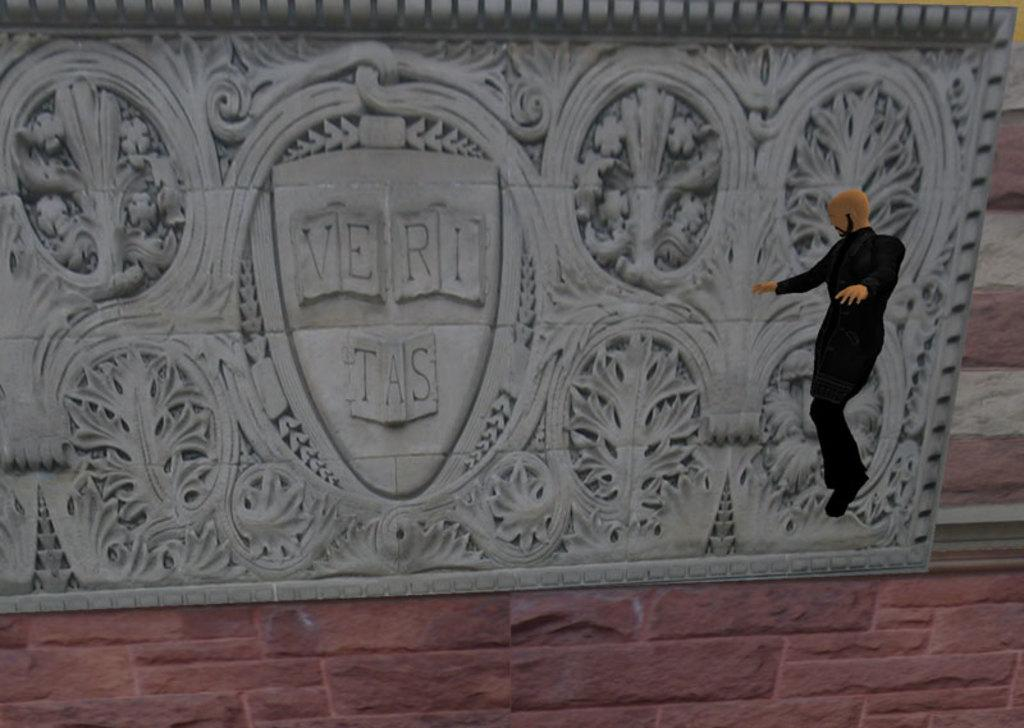What is present on the wall in the image? There is a designed board on the wall. Where is the doll located in the image? The doll is on the right side of the image. Can you describe the wall in the image? The wall has a designed board on it. What type of cave can be seen in the background of the image? There is no cave present in the image; it only features a wall with a designed board and a doll on the right side. 